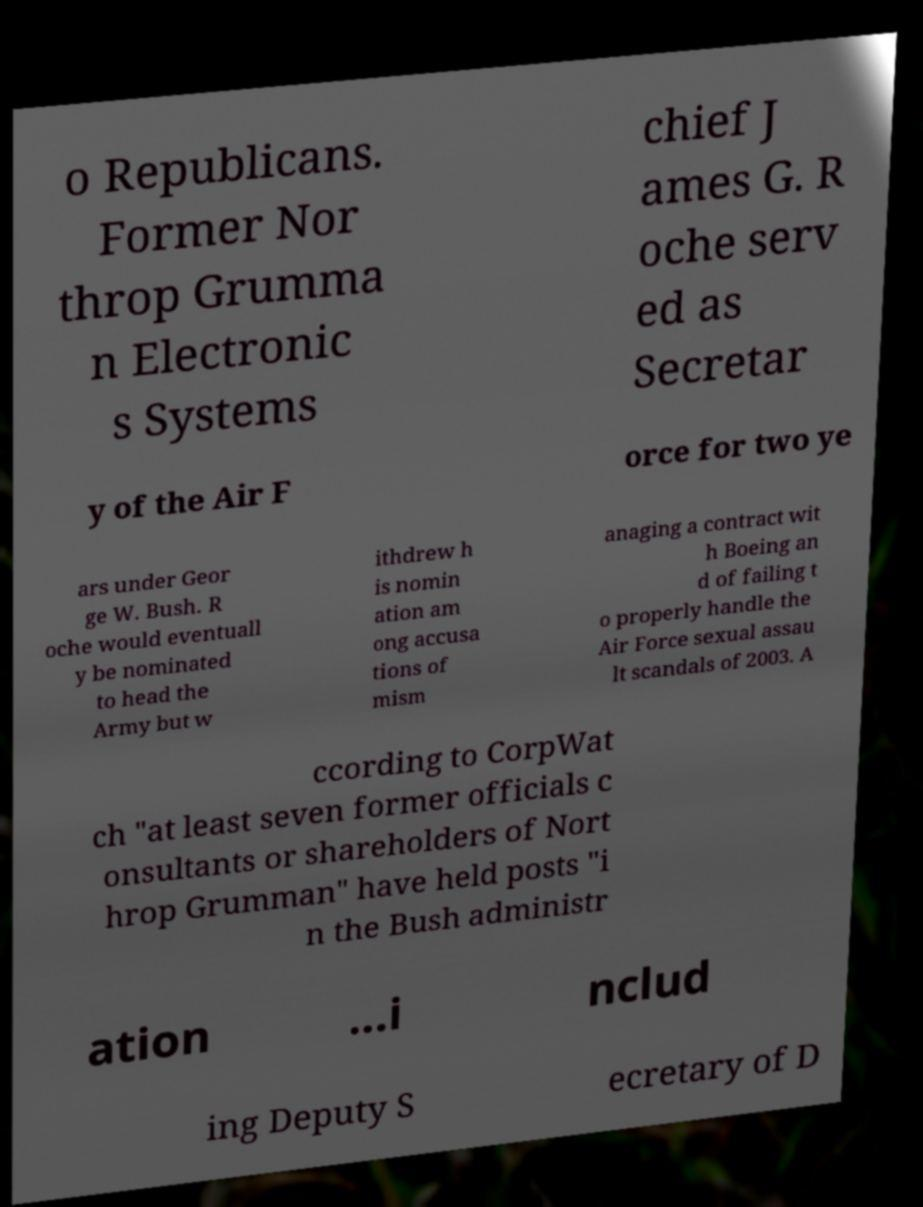There's text embedded in this image that I need extracted. Can you transcribe it verbatim? o Republicans. Former Nor throp Grumma n Electronic s Systems chief J ames G. R oche serv ed as Secretar y of the Air F orce for two ye ars under Geor ge W. Bush. R oche would eventuall y be nominated to head the Army but w ithdrew h is nomin ation am ong accusa tions of mism anaging a contract wit h Boeing an d of failing t o properly handle the Air Force sexual assau lt scandals of 2003. A ccording to CorpWat ch "at least seven former officials c onsultants or shareholders of Nort hrop Grumman" have held posts "i n the Bush administr ation ...i nclud ing Deputy S ecretary of D 